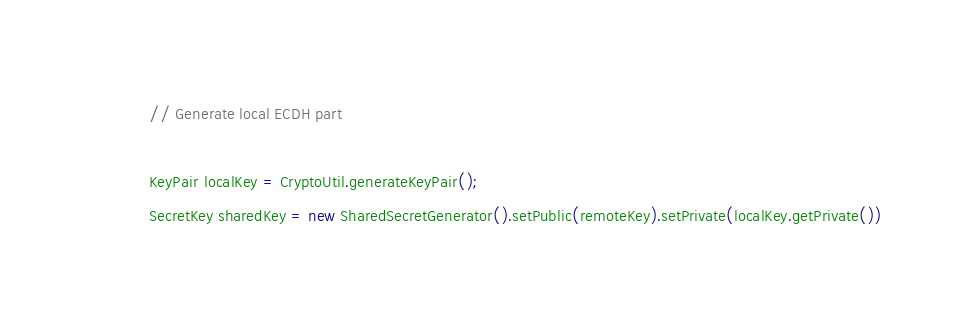Convert code to text. <code><loc_0><loc_0><loc_500><loc_500><_Java_>
            // Generate local ECDH part

            KeyPair localKey = CryptoUtil.generateKeyPair();
            SecretKey sharedKey = new SharedSecretGenerator().setPublic(remoteKey).setPrivate(localKey.getPrivate())</code> 